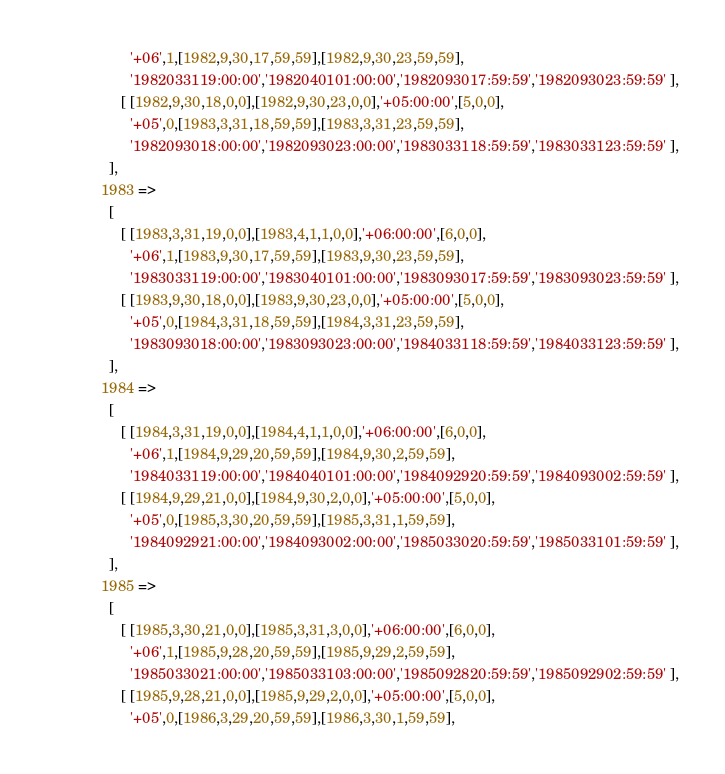Convert code to text. <code><loc_0><loc_0><loc_500><loc_500><_Perl_>          '+06',1,[1982,9,30,17,59,59],[1982,9,30,23,59,59],
          '1982033119:00:00','1982040101:00:00','1982093017:59:59','1982093023:59:59' ],
        [ [1982,9,30,18,0,0],[1982,9,30,23,0,0],'+05:00:00',[5,0,0],
          '+05',0,[1983,3,31,18,59,59],[1983,3,31,23,59,59],
          '1982093018:00:00','1982093023:00:00','1983033118:59:59','1983033123:59:59' ],
     ],
   1983 =>
     [
        [ [1983,3,31,19,0,0],[1983,4,1,1,0,0],'+06:00:00',[6,0,0],
          '+06',1,[1983,9,30,17,59,59],[1983,9,30,23,59,59],
          '1983033119:00:00','1983040101:00:00','1983093017:59:59','1983093023:59:59' ],
        [ [1983,9,30,18,0,0],[1983,9,30,23,0,0],'+05:00:00',[5,0,0],
          '+05',0,[1984,3,31,18,59,59],[1984,3,31,23,59,59],
          '1983093018:00:00','1983093023:00:00','1984033118:59:59','1984033123:59:59' ],
     ],
   1984 =>
     [
        [ [1984,3,31,19,0,0],[1984,4,1,1,0,0],'+06:00:00',[6,0,0],
          '+06',1,[1984,9,29,20,59,59],[1984,9,30,2,59,59],
          '1984033119:00:00','1984040101:00:00','1984092920:59:59','1984093002:59:59' ],
        [ [1984,9,29,21,0,0],[1984,9,30,2,0,0],'+05:00:00',[5,0,0],
          '+05',0,[1985,3,30,20,59,59],[1985,3,31,1,59,59],
          '1984092921:00:00','1984093002:00:00','1985033020:59:59','1985033101:59:59' ],
     ],
   1985 =>
     [
        [ [1985,3,30,21,0,0],[1985,3,31,3,0,0],'+06:00:00',[6,0,0],
          '+06',1,[1985,9,28,20,59,59],[1985,9,29,2,59,59],
          '1985033021:00:00','1985033103:00:00','1985092820:59:59','1985092902:59:59' ],
        [ [1985,9,28,21,0,0],[1985,9,29,2,0,0],'+05:00:00',[5,0,0],
          '+05',0,[1986,3,29,20,59,59],[1986,3,30,1,59,59],</code> 